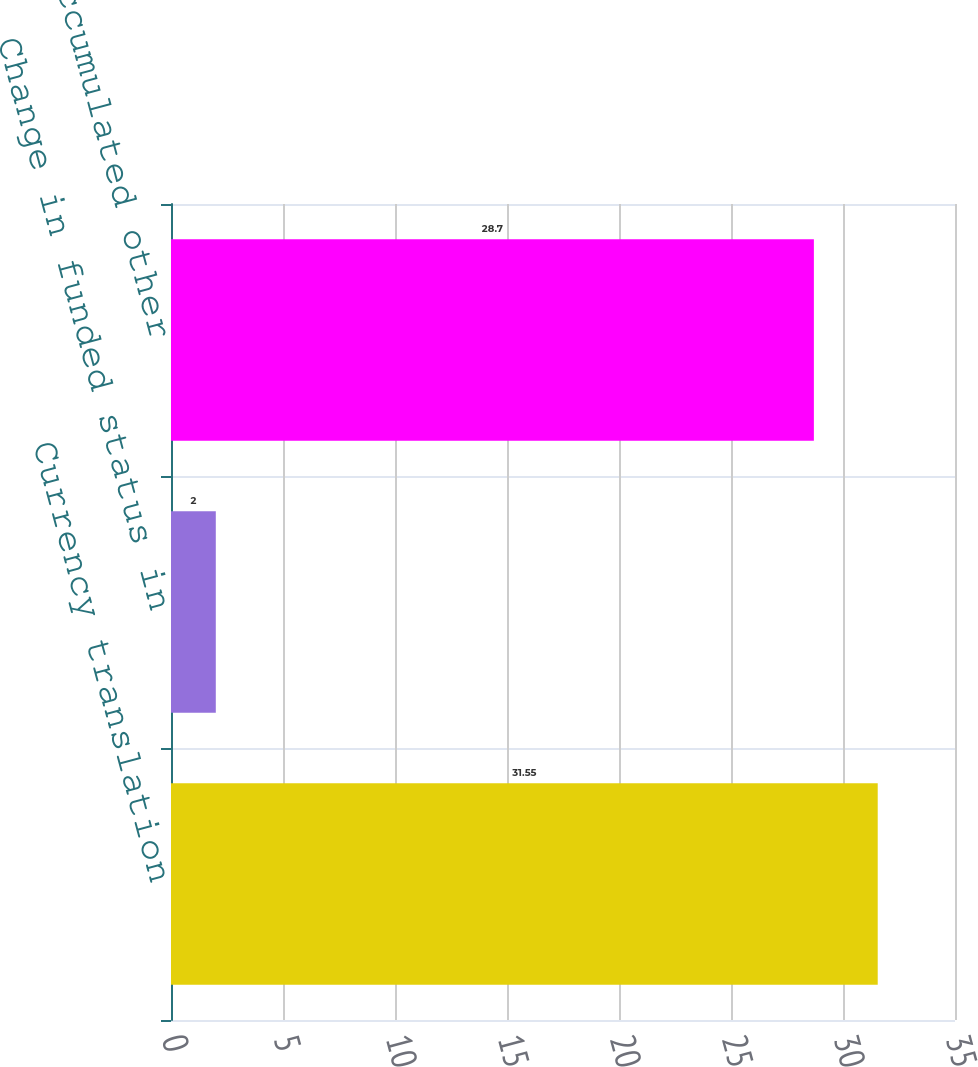Convert chart. <chart><loc_0><loc_0><loc_500><loc_500><bar_chart><fcel>Currency translation<fcel>Change in funded status in<fcel>Accumulated other<nl><fcel>31.55<fcel>2<fcel>28.7<nl></chart> 